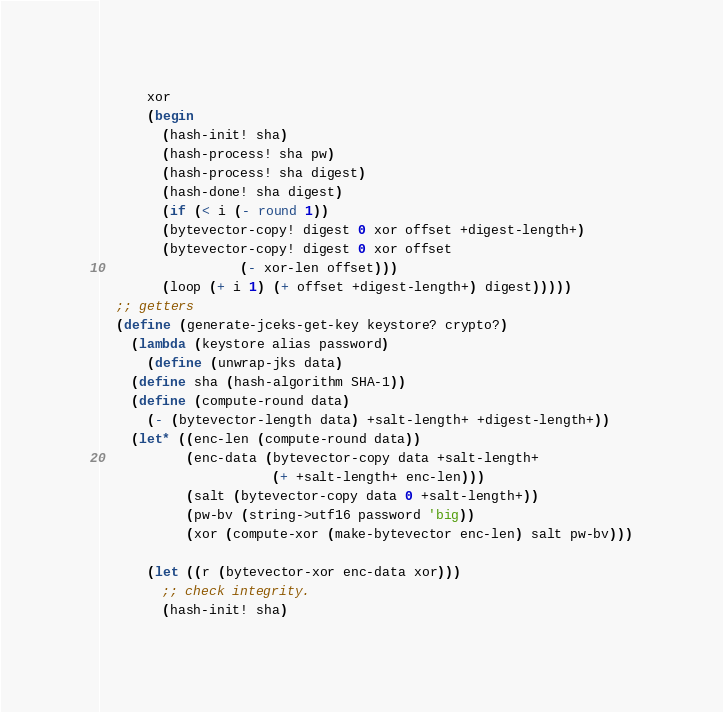<code> <loc_0><loc_0><loc_500><loc_500><_Scheme_>	  xor
	  (begin
	    (hash-init! sha)
	    (hash-process! sha pw)
	    (hash-process! sha digest)
	    (hash-done! sha digest)
	    (if (< i (- round 1))
		(bytevector-copy! digest 0 xor offset +digest-length+)
		(bytevector-copy! digest 0 xor offset 
				  (- xor-len offset)))
	    (loop (+ i 1) (+ offset +digest-length+) digest)))))
  ;; getters
  (define (generate-jceks-get-key keystore? crypto?)
    (lambda (keystore alias password)
      (define (unwrap-jks data)
	(define sha (hash-algorithm SHA-1))
	(define (compute-round data)
	  (- (bytevector-length data) +salt-length+ +digest-length+))
	(let* ((enc-len (compute-round data))
	       (enc-data (bytevector-copy data +salt-length+
					  (+ +salt-length+ enc-len)))
	       (salt (bytevector-copy data 0 +salt-length+))
	       (pw-bv (string->utf16 password 'big))
	       (xor (compute-xor (make-bytevector enc-len) salt pw-bv)))

	  (let ((r (bytevector-xor enc-data xor)))
	    ;; check integrity.
	    (hash-init! sha)</code> 